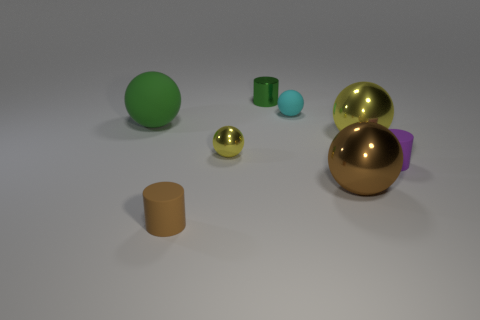Add 2 small balls. How many objects exist? 10 Subtract all rubber balls. How many balls are left? 3 Subtract all cyan cylinders. How many brown balls are left? 1 Subtract all brown balls. How many balls are left? 4 Subtract 0 purple cubes. How many objects are left? 8 Subtract all cylinders. How many objects are left? 5 Subtract all red cylinders. Subtract all yellow balls. How many cylinders are left? 3 Subtract all small brown rubber objects. Subtract all tiny yellow things. How many objects are left? 6 Add 1 purple matte cylinders. How many purple matte cylinders are left? 2 Add 6 large green rubber balls. How many large green rubber balls exist? 7 